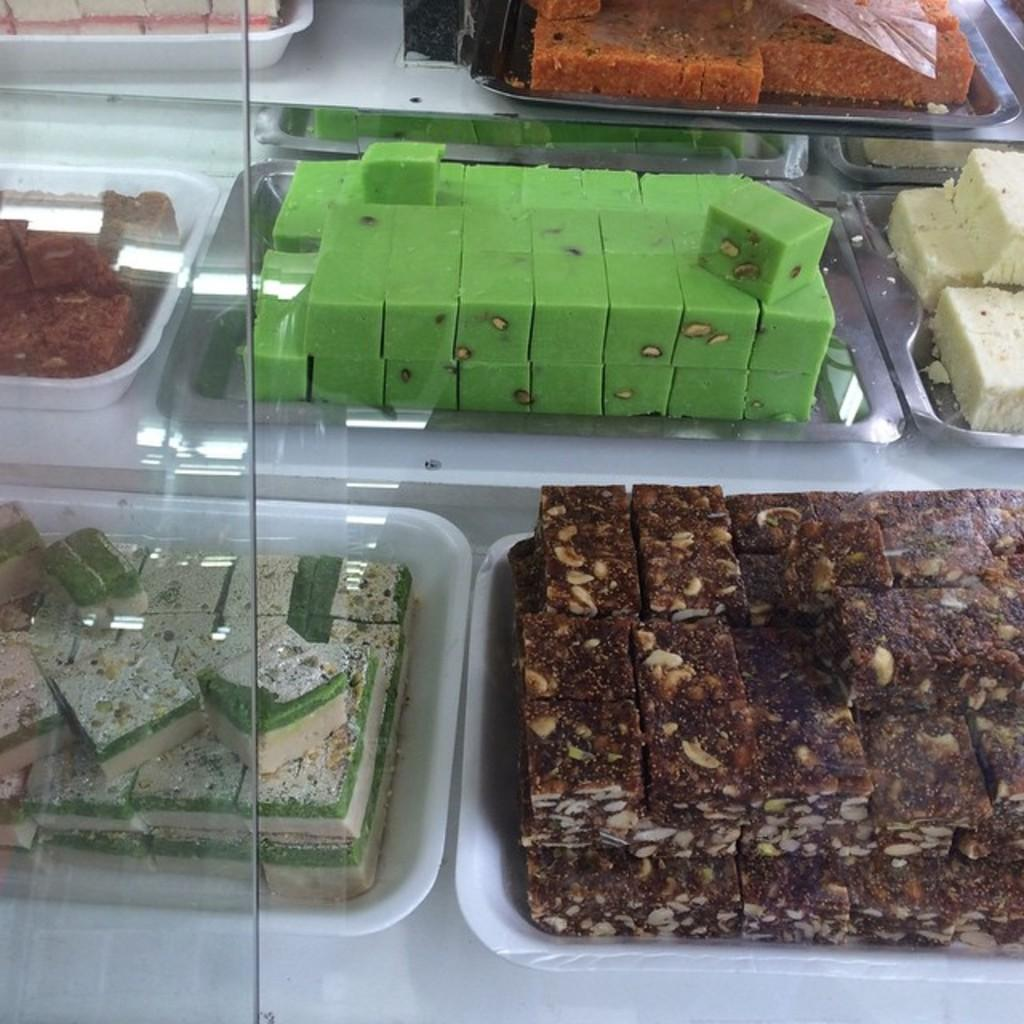What object is visible in the image? There is a glass in the image. What is located behind the glass? There are plates with sweets behind the glass. What type of worm can be seen flying a kite on top of the hat in the image? There is no worm, kite, or hat present in the image. 